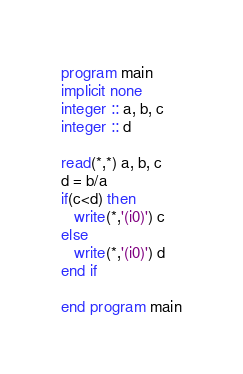<code> <loc_0><loc_0><loc_500><loc_500><_FORTRAN_>program main
implicit none
integer :: a, b, c
integer :: d

read(*,*) a, b, c
d = b/a
if(c<d) then
   write(*,'(i0)') c
else
   write(*,'(i0)') d
end if

end program main
</code> 